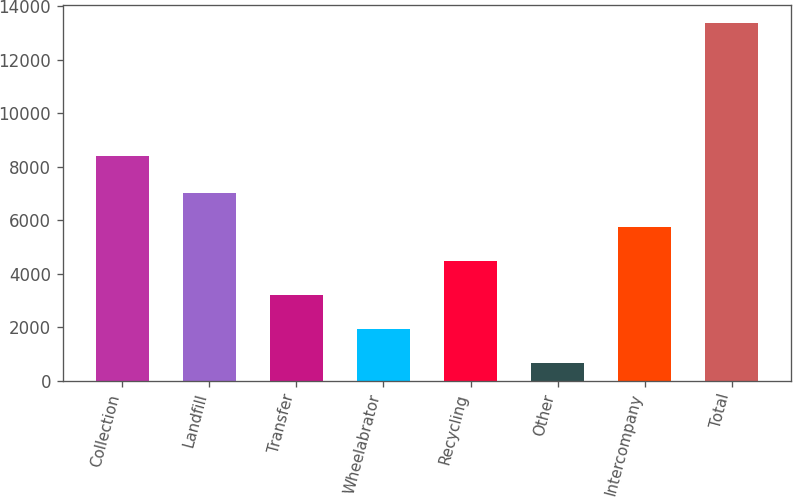Convert chart to OTSL. <chart><loc_0><loc_0><loc_500><loc_500><bar_chart><fcel>Collection<fcel>Landfill<fcel>Transfer<fcel>Wheelabrator<fcel>Recycling<fcel>Other<fcel>Intercompany<fcel>Total<nl><fcel>8406<fcel>7016.5<fcel>3199.6<fcel>1927.3<fcel>4471.9<fcel>655<fcel>5744.2<fcel>13378<nl></chart> 